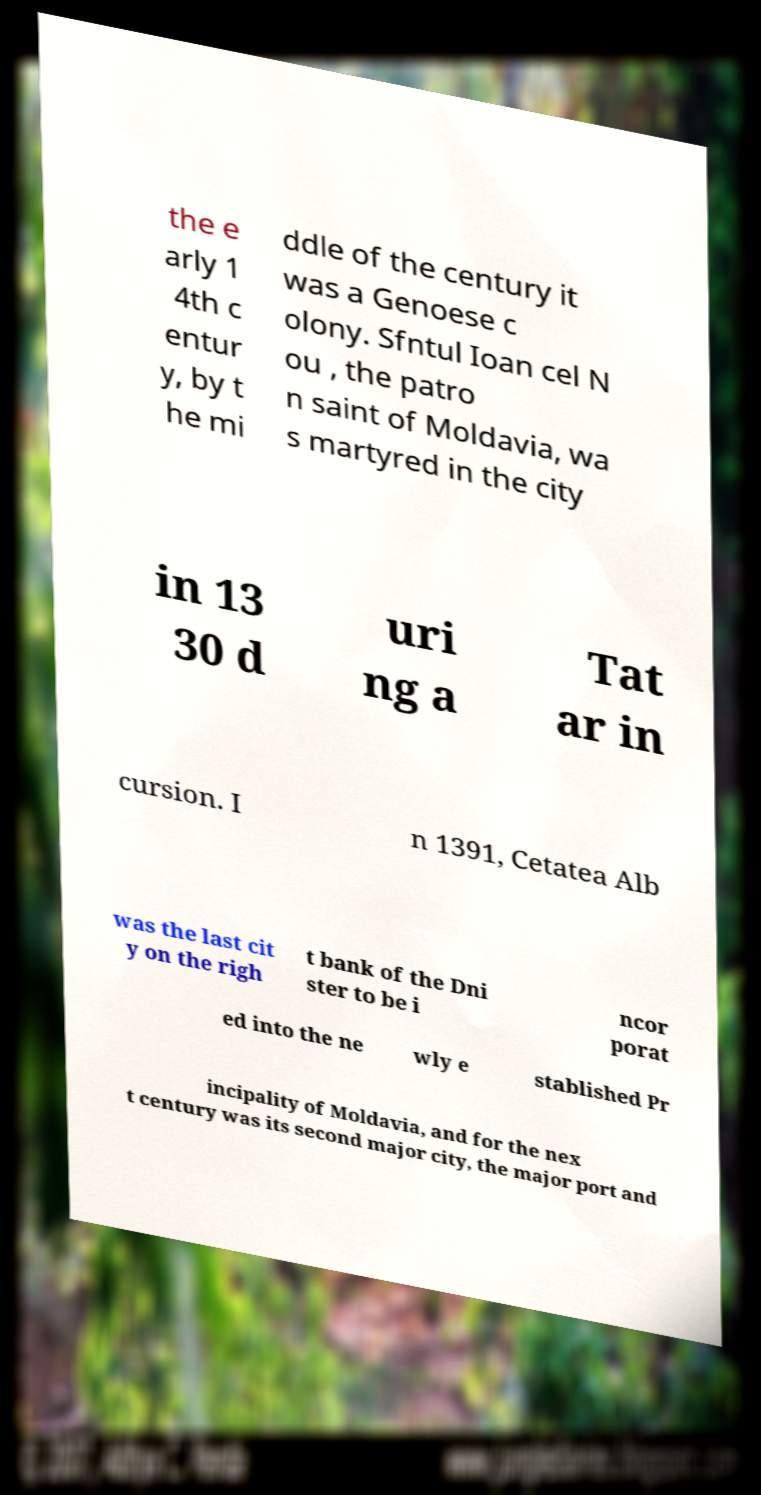Could you assist in decoding the text presented in this image and type it out clearly? the e arly 1 4th c entur y, by t he mi ddle of the century it was a Genoese c olony. Sfntul Ioan cel N ou , the patro n saint of Moldavia, wa s martyred in the city in 13 30 d uri ng a Tat ar in cursion. I n 1391, Cetatea Alb was the last cit y on the righ t bank of the Dni ster to be i ncor porat ed into the ne wly e stablished Pr incipality of Moldavia, and for the nex t century was its second major city, the major port and 